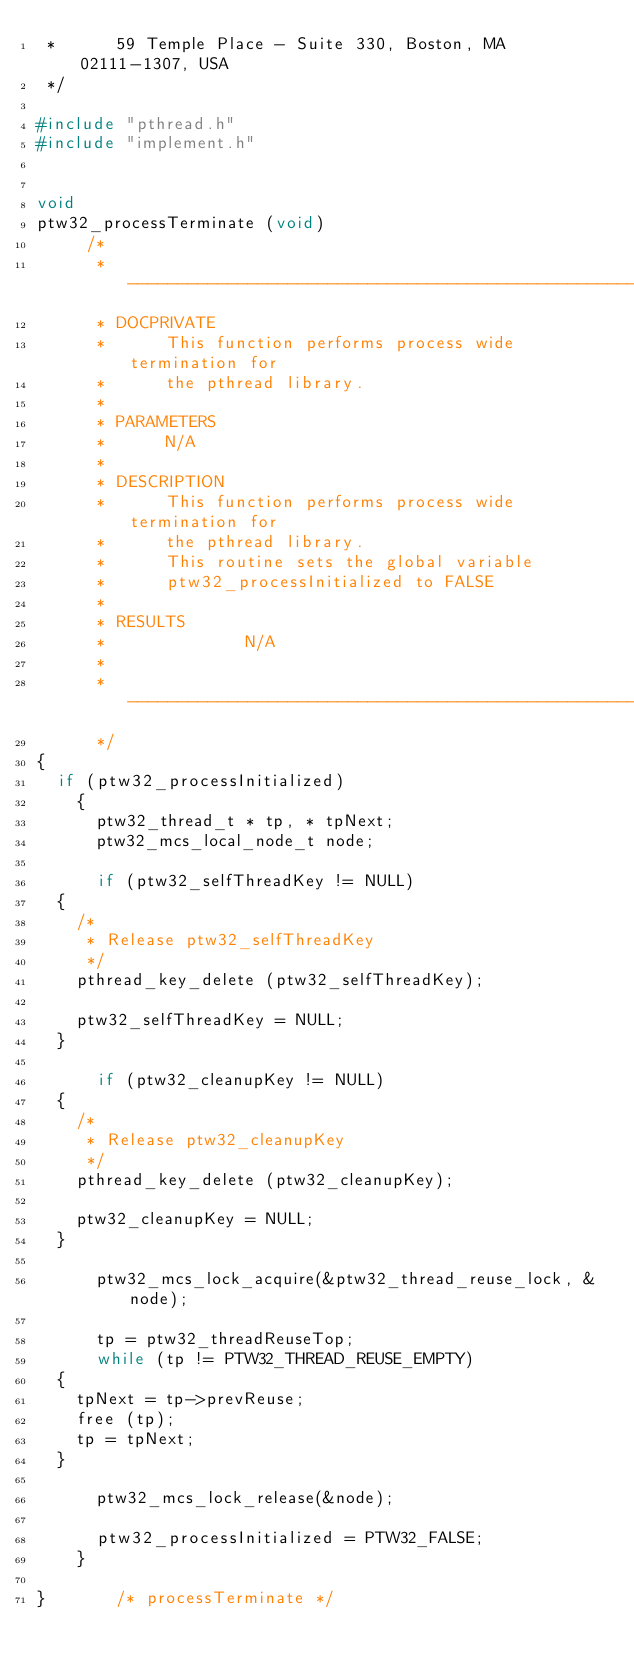Convert code to text. <code><loc_0><loc_0><loc_500><loc_500><_C_> *      59 Temple Place - Suite 330, Boston, MA 02111-1307, USA
 */

#include "pthread.h"
#include "implement.h"


void
ptw32_processTerminate (void)
     /*
      * ------------------------------------------------------
      * DOCPRIVATE
      *      This function performs process wide termination for
      *      the pthread library.
      *
      * PARAMETERS
      *      N/A
      *
      * DESCRIPTION
      *      This function performs process wide termination for
      *      the pthread library.
      *      This routine sets the global variable
      *      ptw32_processInitialized to FALSE
      *
      * RESULTS
      *              N/A
      *
      * ------------------------------------------------------
      */
{
  if (ptw32_processInitialized)
    {
      ptw32_thread_t * tp, * tpNext;
      ptw32_mcs_local_node_t node;

      if (ptw32_selfThreadKey != NULL)
	{
	  /*
	   * Release ptw32_selfThreadKey
	   */
	  pthread_key_delete (ptw32_selfThreadKey);

	  ptw32_selfThreadKey = NULL;
	}

      if (ptw32_cleanupKey != NULL)
	{
	  /*
	   * Release ptw32_cleanupKey
	   */
	  pthread_key_delete (ptw32_cleanupKey);

	  ptw32_cleanupKey = NULL;
	}

      ptw32_mcs_lock_acquire(&ptw32_thread_reuse_lock, &node);

      tp = ptw32_threadReuseTop;
      while (tp != PTW32_THREAD_REUSE_EMPTY)
	{
	  tpNext = tp->prevReuse;
	  free (tp);
	  tp = tpNext;
	}

      ptw32_mcs_lock_release(&node);

      ptw32_processInitialized = PTW32_FALSE;
    }

}				/* processTerminate */
</code> 